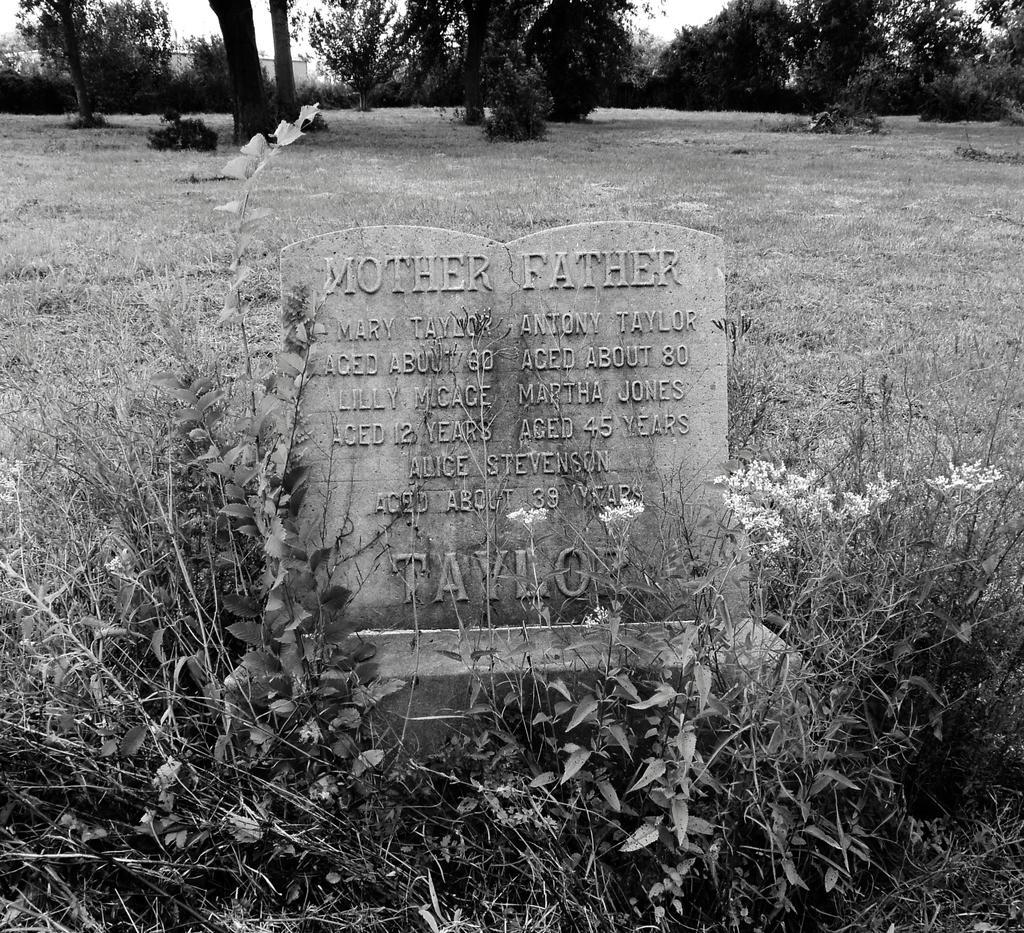Describe this image in one or two sentences. In this picture I can see text on the stone and few plants and grass on the ground and I can see trees. 